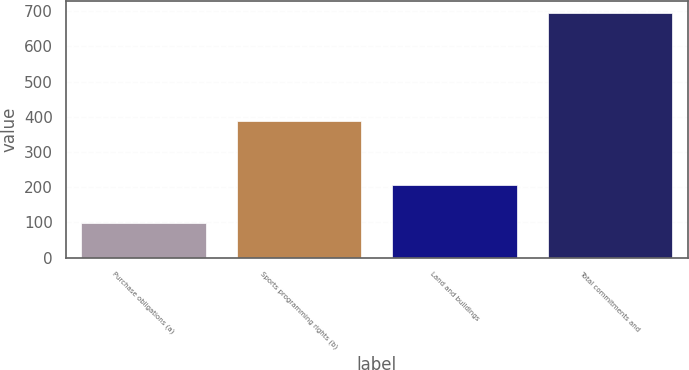Convert chart. <chart><loc_0><loc_0><loc_500><loc_500><bar_chart><fcel>Purchase obligations (a)<fcel>Sports programming rights (b)<fcel>Land and buildings<fcel>Total commitments and<nl><fcel>99<fcel>388<fcel>207<fcel>694<nl></chart> 